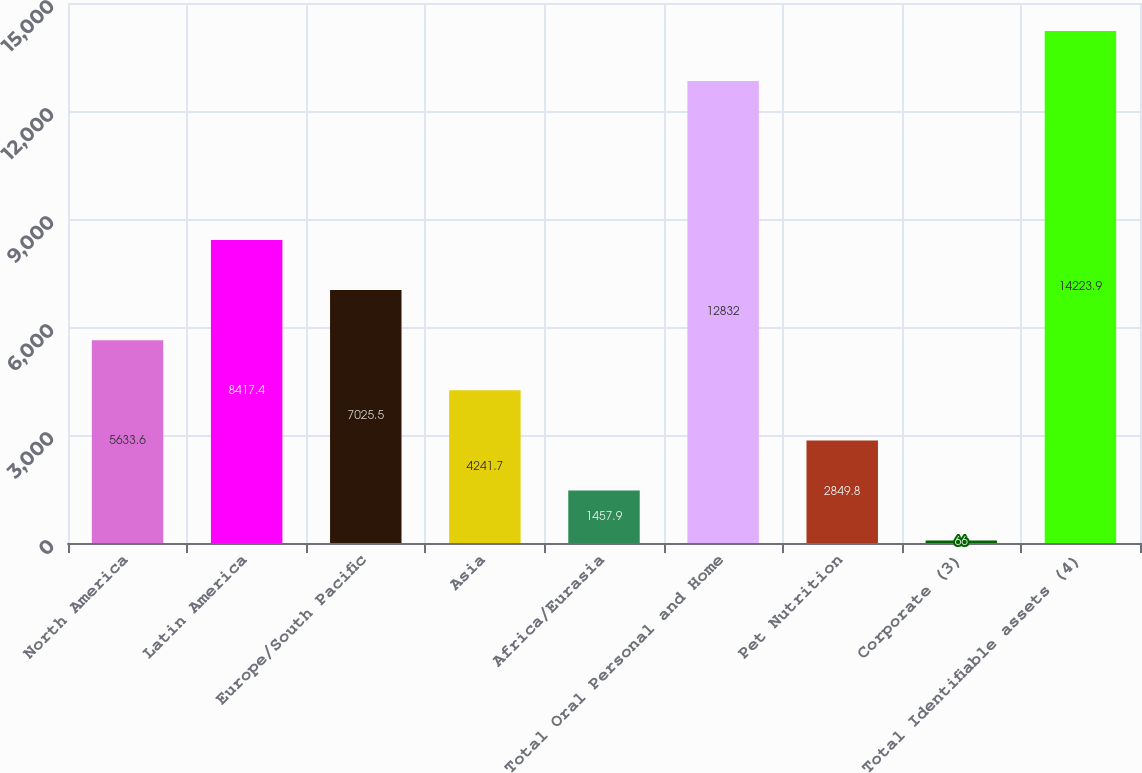<chart> <loc_0><loc_0><loc_500><loc_500><bar_chart><fcel>North America<fcel>Latin America<fcel>Europe/South Pacific<fcel>Asia<fcel>Africa/Eurasia<fcel>Total Oral Personal and Home<fcel>Pet Nutrition<fcel>Corporate (3)<fcel>Total Identifiable assets (4)<nl><fcel>5633.6<fcel>8417.4<fcel>7025.5<fcel>4241.7<fcel>1457.9<fcel>12832<fcel>2849.8<fcel>66<fcel>14223.9<nl></chart> 